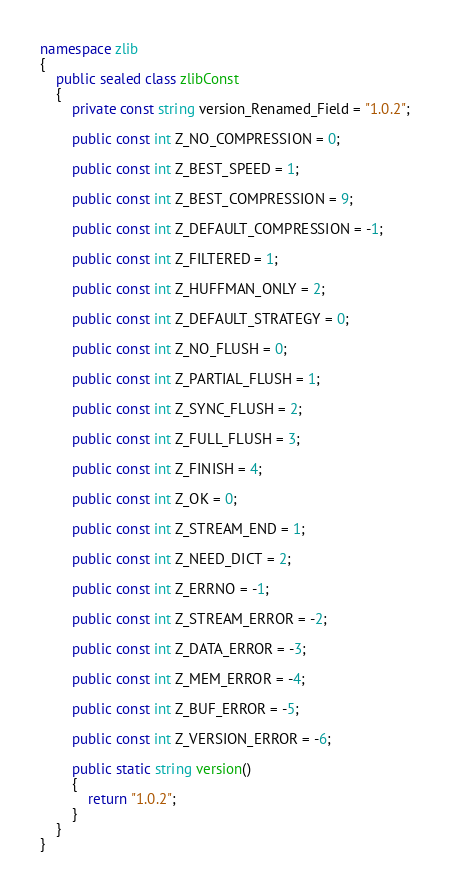<code> <loc_0><loc_0><loc_500><loc_500><_C#_>namespace zlib
{
	public sealed class zlibConst
	{
		private const string version_Renamed_Field = "1.0.2";

		public const int Z_NO_COMPRESSION = 0;

		public const int Z_BEST_SPEED = 1;

		public const int Z_BEST_COMPRESSION = 9;

		public const int Z_DEFAULT_COMPRESSION = -1;

		public const int Z_FILTERED = 1;

		public const int Z_HUFFMAN_ONLY = 2;

		public const int Z_DEFAULT_STRATEGY = 0;

		public const int Z_NO_FLUSH = 0;

		public const int Z_PARTIAL_FLUSH = 1;

		public const int Z_SYNC_FLUSH = 2;

		public const int Z_FULL_FLUSH = 3;

		public const int Z_FINISH = 4;

		public const int Z_OK = 0;

		public const int Z_STREAM_END = 1;

		public const int Z_NEED_DICT = 2;

		public const int Z_ERRNO = -1;

		public const int Z_STREAM_ERROR = -2;

		public const int Z_DATA_ERROR = -3;

		public const int Z_MEM_ERROR = -4;

		public const int Z_BUF_ERROR = -5;

		public const int Z_VERSION_ERROR = -6;

		public static string version()
		{
			return "1.0.2";
		}
	}
}
</code> 